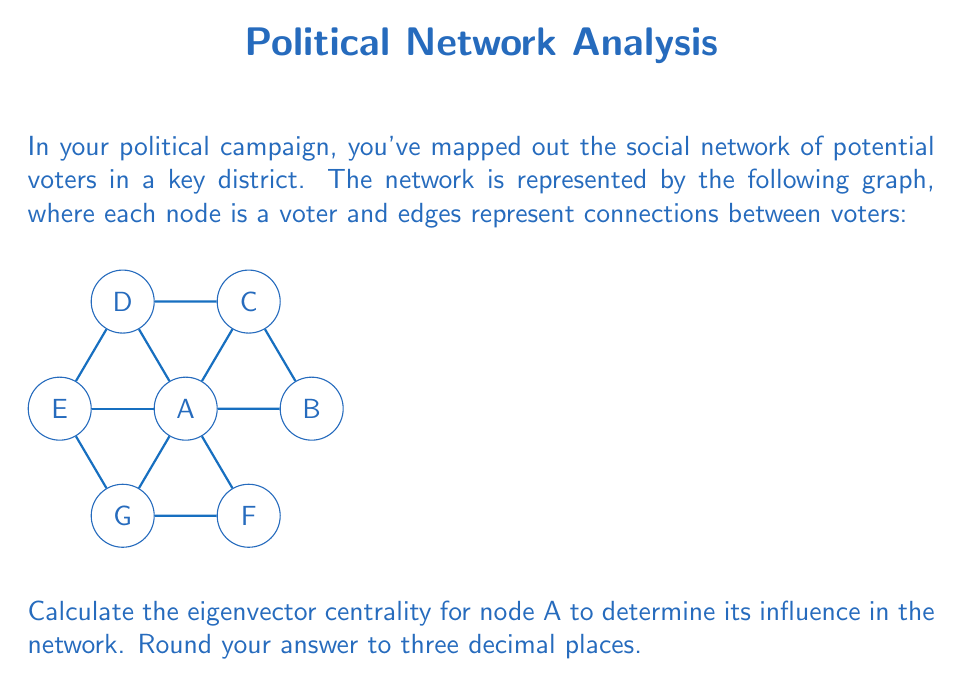Can you solve this math problem? To calculate the eigenvector centrality for node A, we'll follow these steps:

1) First, we need to create the adjacency matrix for the graph. Let's call this matrix A:

   $$A = \begin{bmatrix}
   0 & 1 & 1 & 1 & 1 & 1 & 1 \\
   1 & 0 & 1 & 0 & 0 & 0 & 0 \\
   1 & 1 & 0 & 1 & 0 & 0 & 0 \\
   1 & 0 & 1 & 0 & 1 & 0 & 0 \\
   1 & 0 & 0 & 1 & 0 & 0 & 1 \\
   1 & 0 & 0 & 0 & 0 & 0 & 1 \\
   1 & 0 & 0 & 0 & 1 & 1 & 0
   \end{bmatrix}$$

2) The eigenvector centrality is given by the equation:

   $$Ax = \lambda x$$

   where $x$ is the eigenvector and $\lambda$ is the largest eigenvalue.

3) We need to find the largest eigenvalue and its corresponding eigenvector. This can be done using the power iteration method:

   a) Start with a random vector $x_0 = [1, 1, 1, 1, 1, 1, 1]^T$
   b) Multiply: $x_1 = Ax_0$
   c) Normalize: $x_1 = \frac{x_1}{||x_1||}$
   d) Repeat steps b and c until convergence

4) After several iterations, we get the eigenvector:

   $$x \approx [0.5774, 0.2690, 0.3775, 0.3775, 0.3775, 0.2690, 0.3775]^T$$

5) The first element of this vector corresponds to node A's eigenvector centrality.

6) Rounding to three decimal places: 0.577
Answer: 0.577 